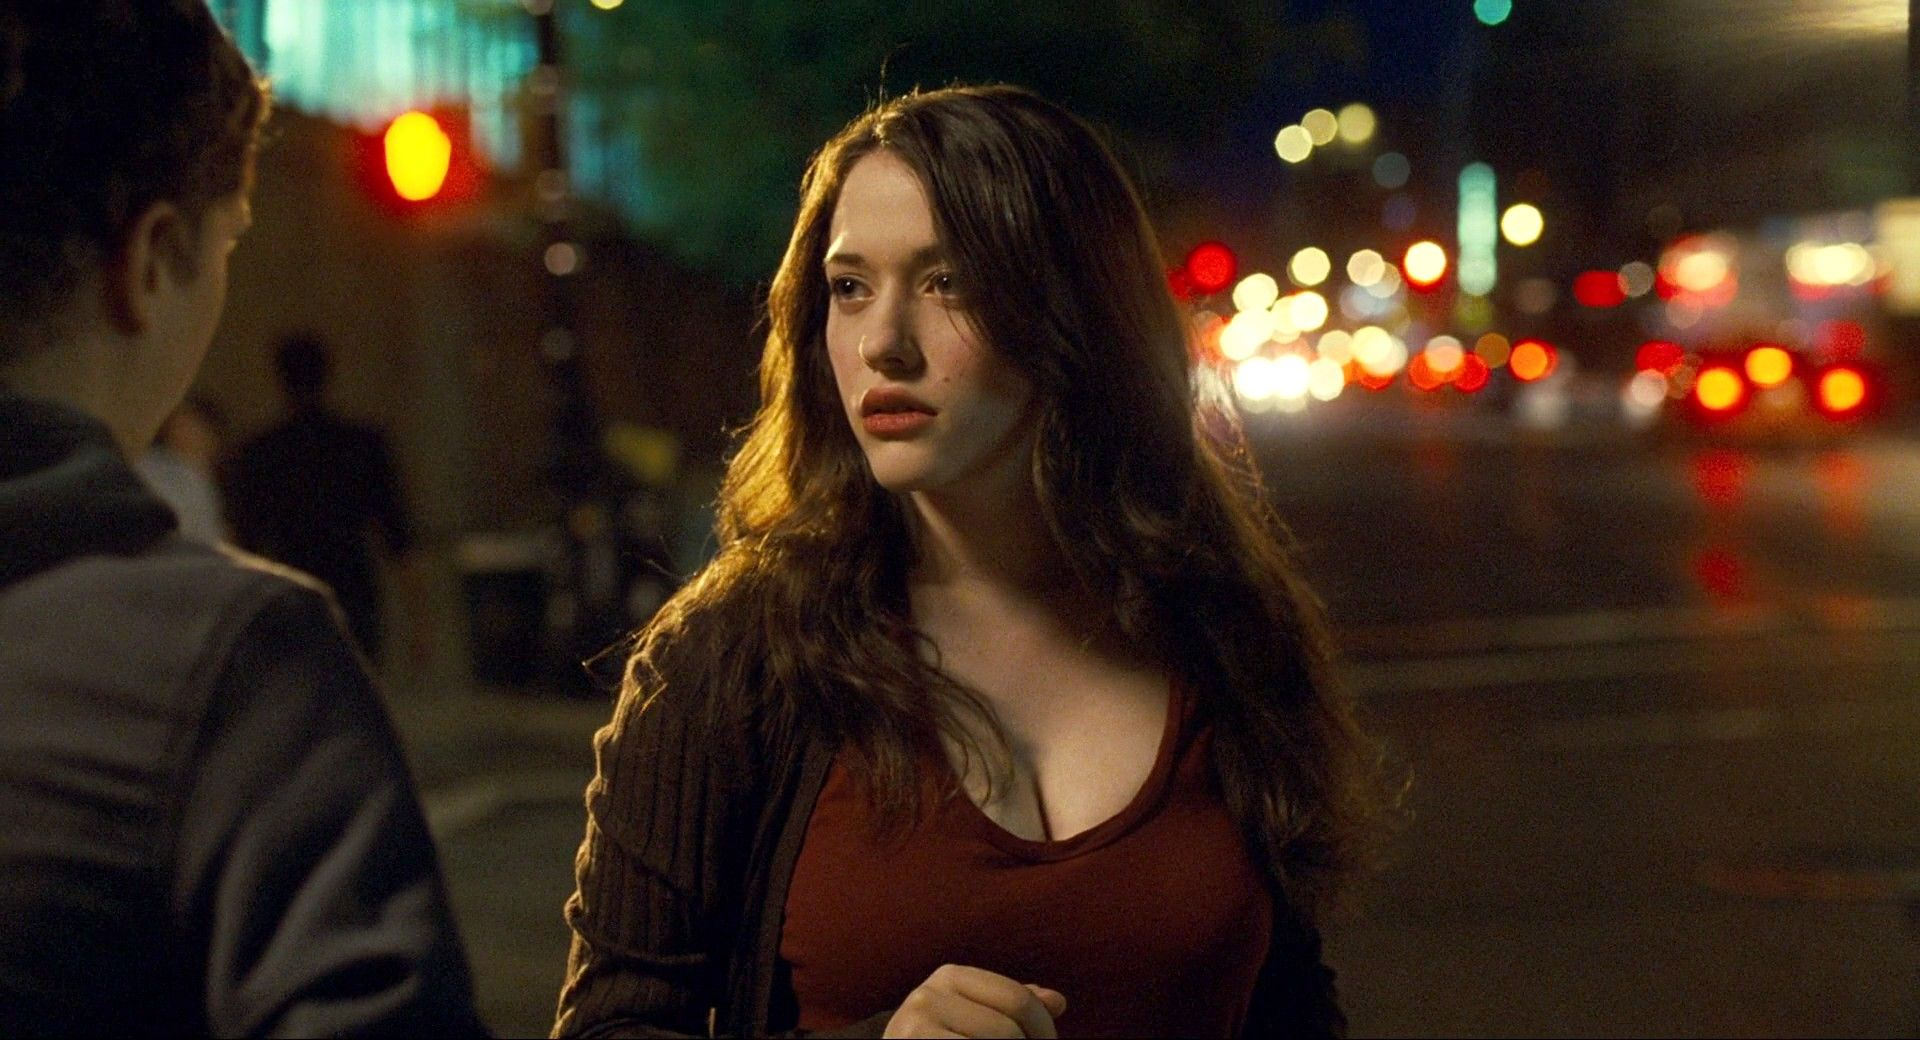Analyze the image in a comprehensive and detailed manner. In the image, a young woman with long, wavy brown hair stands on a bustling city street at night. She is positioned slightly off-center and appears to be in a moment of deep contemplation, looking off to the side as if she’s lost in thought or anticipating someone’s arrival. Her attire is casual yet stylish; she wears a dark jacket over a vibrant red top that significantly contrasts with the background. The scene is illuminated by blurred city lights and the streaks of passing cars, creating a dynamic, atmospheric backdrop filled with the warmth and activity of city nightlife. The image captures a vivid narrative moment, suggestive of a story centered around this woman, where her expression and the urban setting provoke curiosity about her thoughts and circumstances. 